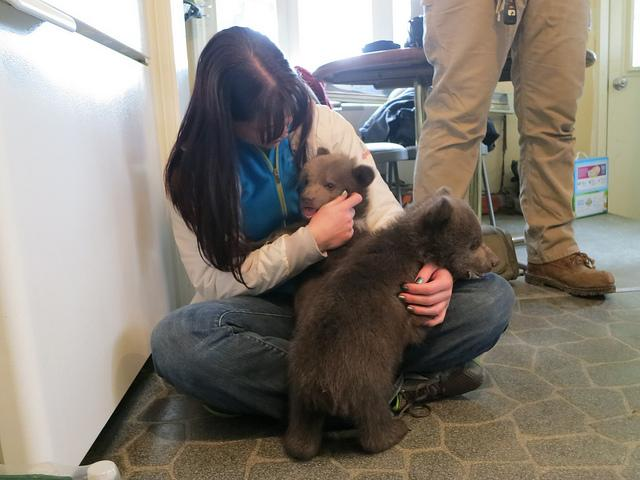The girl is playing with what animals? Please explain your reasoning. bears. The woman is sitting on the floor playing with orphaned (possibly) cubs. 